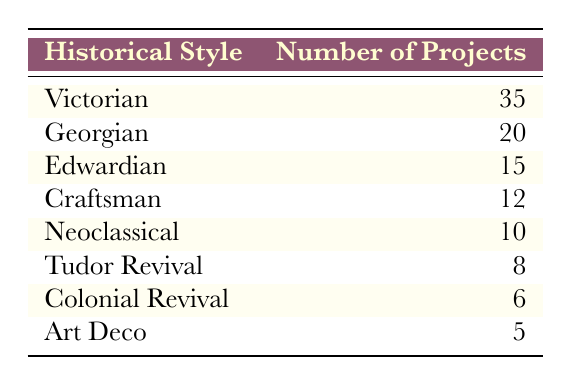What is the total number of projects listed for Victorian style? The table shows that the Victorian style has 35 projects listed. So, the total number of projects for the Victorian style is simply the number directly displayed in its row, which is 35.
Answer: 35 Which style has the second highest number of projects? By comparing the number of projects listed for each style, Victorian has the most at 35, but Georgian, with 20 projects, is the next highest. Thus, Georgian is the second highest.
Answer: Georgian What is the average number of projects across all styles? To find the average, first we sum all the projects (35 + 20 + 15 + 12 + 10 + 8 + 6 + 5 = 111). There are 8 styles in total. Thus, we divide the sum by the number of styles (111/8) which gives approximately 13.875.
Answer: 13.875 Is there a style with exactly 10 projects? The table shows that Neoclassical style has 10 projects listed. Therefore, there is indeed a style with exactly 10 projects.
Answer: Yes How many more projects does Victorian have compared to Art Deco? By checking their project numbers, Victorian has 35 projects while Art Deco has 5. The difference is calculated as 35 - 5 = 30 projects more for Victorian.
Answer: 30 Which style has the least number of projects, and how many are there? From the table comparison, Art Deco appears to have the least number of projects listed at 5. It is the only style with this lowest count.
Answer: Art Deco, 5 If the projects for Colonial Revival were doubled, what would be the new total? Colonial Revival currently has 6 projects. Doubling this gives us 6 * 2 = 12. We then need to add this to the original total count to find the new number, but since it only affects that style, the new count for Colonial Revival would just be 12.
Answer: 12 What is the total number of projects for styles that are from the Victorian era (Victorian, Edwardian, Craftsman)? We first determine the projects for each of these styles: Victorian (35), Edwardian (15), and Craftsman (12). Adding these together gives 35 + 15 + 12 = 62 total projects for these styles.
Answer: 62 Is Craftsman style more popular than Tudor Revival? Checking the numbers, Craftsman style has 12 projects, while Tudor Revival has 8. Therefore, Craftsman style is more popular than Tudor Revival.
Answer: Yes 